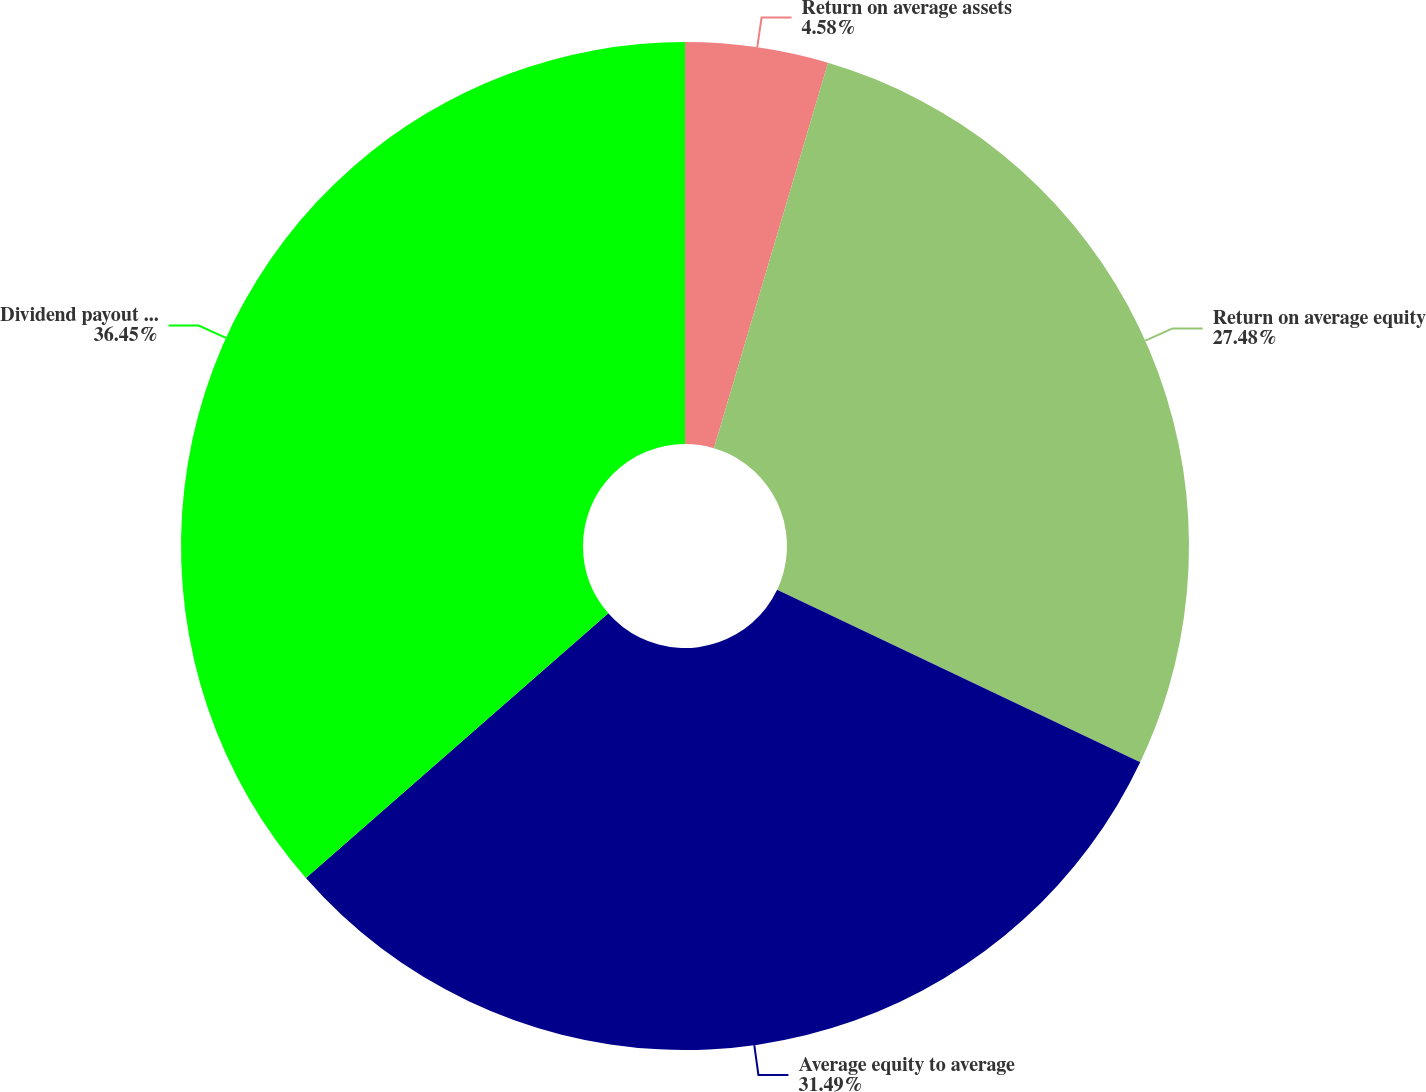<chart> <loc_0><loc_0><loc_500><loc_500><pie_chart><fcel>Return on average assets<fcel>Return on average equity<fcel>Average equity to average<fcel>Dividend payout ratio<nl><fcel>4.58%<fcel>27.48%<fcel>31.49%<fcel>36.45%<nl></chart> 